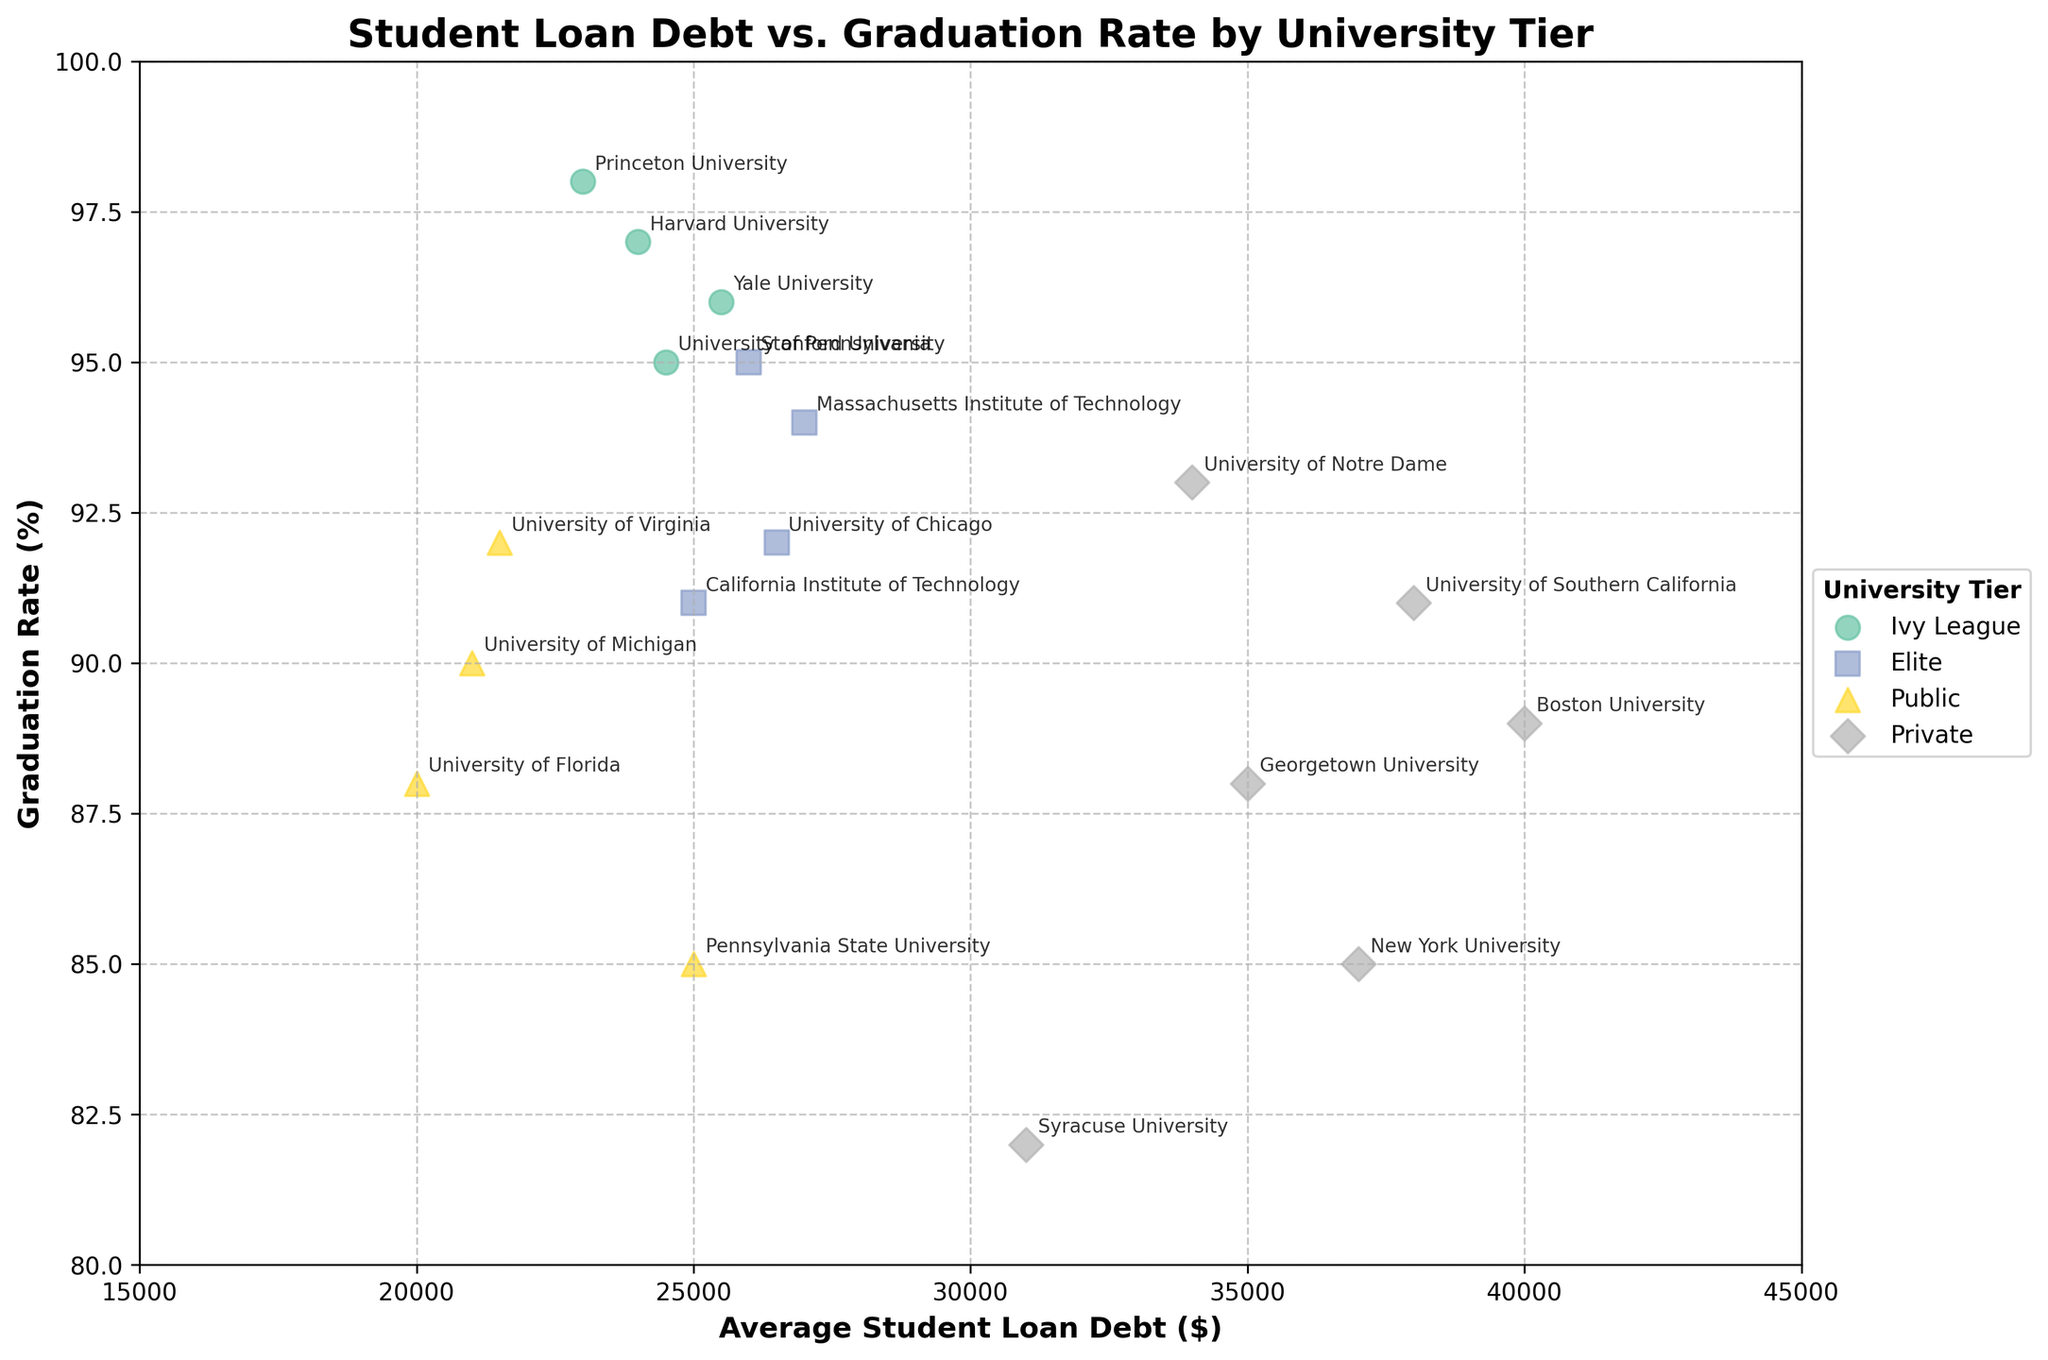What is the title of the plot? The title of the plot is located at the top center and is clearly labeled for context.
Answer: Student Loan Debt vs. Graduation Rate by University Tier Which university has the highest Student Loan Debt? By examining the horizontal axis showing Average Student Loan Debt and locating the highest point, we see that the university label closest to this value is Boston University.
Answer: Boston University What is the Graduation Rate of the Massachusetts Institute of Technology? Find the point labeled "Massachusetts Institute of Technology" and look at its vertical position relative to the Graduation Rate axis.
Answer: 94% Which university tier has the most universities with an average Student Loan Debt of over $30,000? Identify the tier each data point belongs to and count the points with an Average Student Loan Debt greater than $30,000. The Private tier has the most universities meeting this criterion.
Answer: Private What is the average Graduation Rate for the Ivy League tier? Calculate the mean by summing the Graduation Rates of Ivy League universities (97, 96, 98, 95) and dividing by the total number, which is 4: (97 + 96 + 98 + 95) / 4 = 96.5.
Answer: 96.5% Is there a university with both low Student Loan Debt and high Graduation Rate in the Public tier? Look for a university within the Public tier that has a lower Average Student Loan Debt and a higher Graduation Rate. The University of Florida, with a debt of $20,000 and a graduation rate of 88%, fits this criterion.
Answer: Yes Which university has a higher Graduation Rate: Yale University or the University of Pennsylvania? Compare the vertical positions of the points labeled "Yale University" and "University of Pennsylvania." Yale University has a Graduation Rate of 96%, while the University of Pennsylvania has 95%.
Answer: Yale University Between Private and Public universities, which group has a university with the highest Student Loan Debt, and what is that value? Compare the highest points regarding Student Loan Debt in both Private and Public. The highest Private university debt is Boston University ($40,000), while the highest Public is Pennsylvania State University ($25,000).
Answer: Private, $40,000 